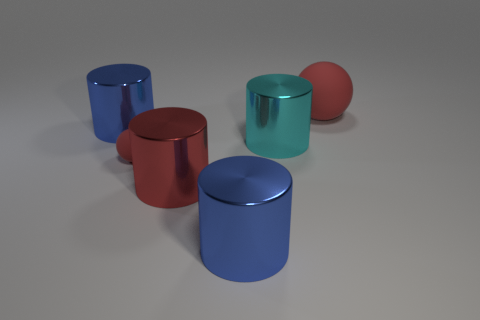Subtract all big red cylinders. How many cylinders are left? 3 Add 3 large balls. How many objects exist? 9 Subtract all red cylinders. How many cylinders are left? 3 Subtract all spheres. How many objects are left? 4 Subtract 4 cylinders. How many cylinders are left? 0 Add 6 blue shiny cylinders. How many blue shiny cylinders exist? 8 Subtract 0 brown cubes. How many objects are left? 6 Subtract all blue spheres. Subtract all brown blocks. How many spheres are left? 2 Subtract all green balls. How many green cylinders are left? 0 Subtract all large red cylinders. Subtract all small objects. How many objects are left? 4 